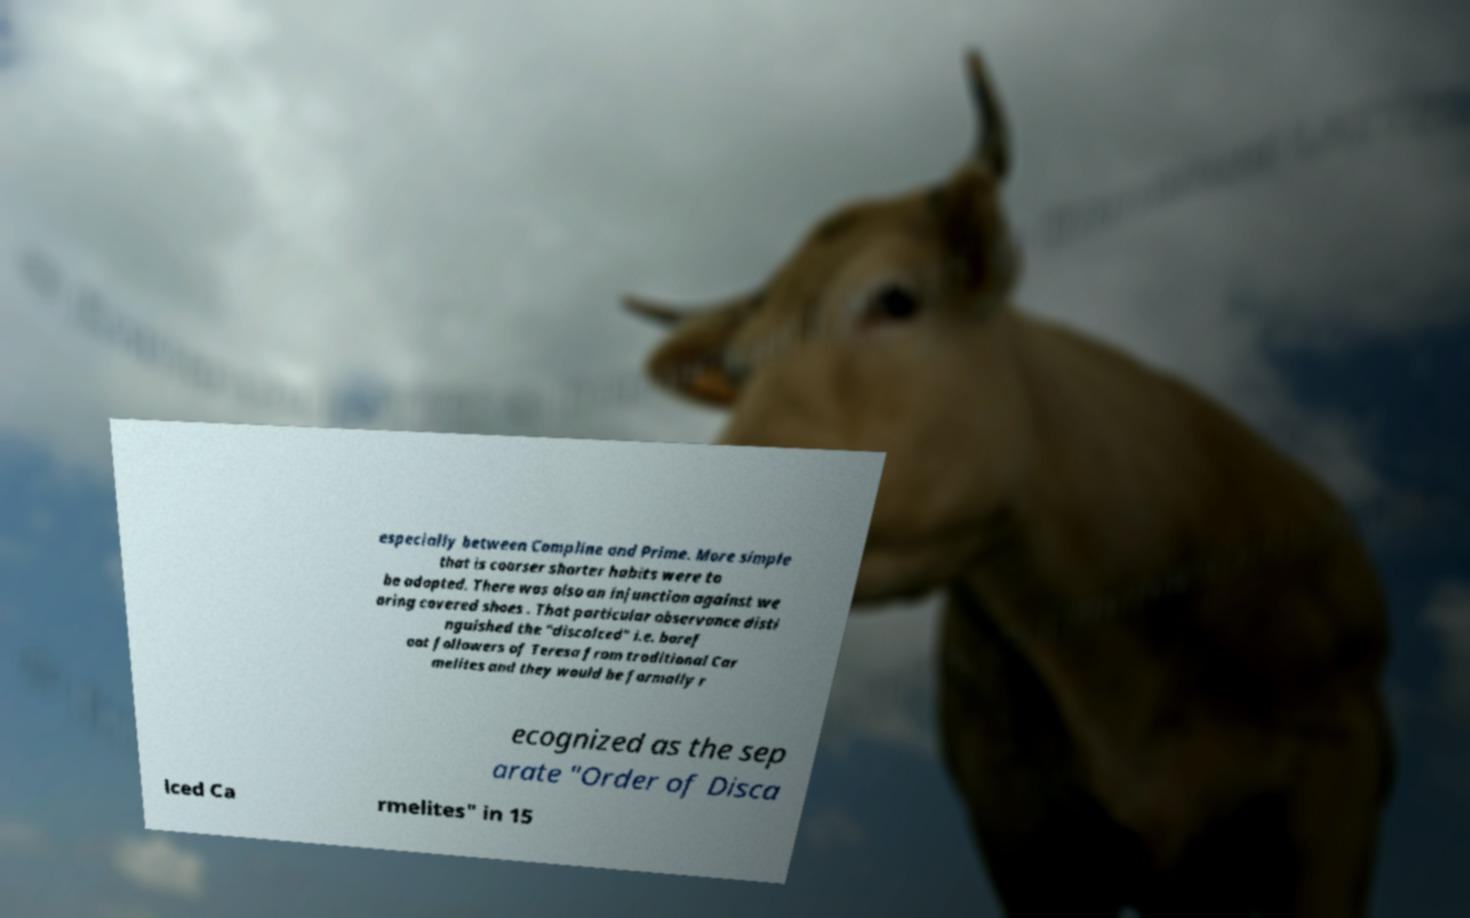Could you assist in decoding the text presented in this image and type it out clearly? especially between Compline and Prime. More simple that is coarser shorter habits were to be adopted. There was also an injunction against we aring covered shoes . That particular observance disti nguished the "discalced" i.e. baref oot followers of Teresa from traditional Car melites and they would be formally r ecognized as the sep arate "Order of Disca lced Ca rmelites" in 15 